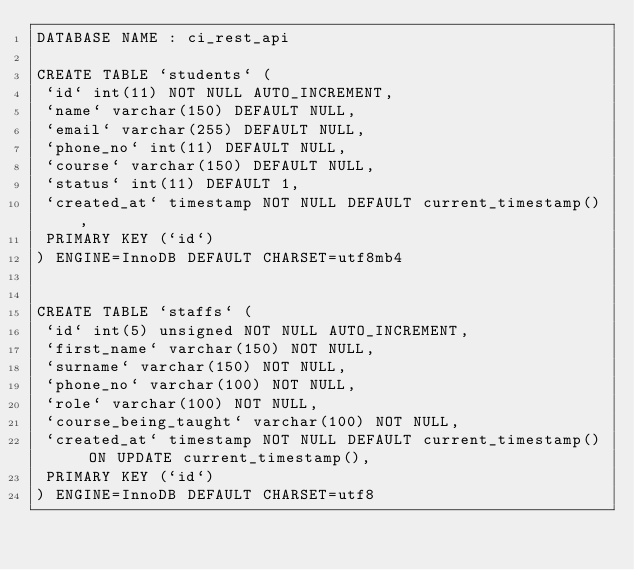<code> <loc_0><loc_0><loc_500><loc_500><_SQL_>DATABASE NAME : ci_rest_api

CREATE TABLE `students` (
 `id` int(11) NOT NULL AUTO_INCREMENT,
 `name` varchar(150) DEFAULT NULL,
 `email` varchar(255) DEFAULT NULL,
 `phone_no` int(11) DEFAULT NULL,
 `course` varchar(150) DEFAULT NULL,
 `status` int(11) DEFAULT 1,
 `created_at` timestamp NOT NULL DEFAULT current_timestamp(),
 PRIMARY KEY (`id`)
) ENGINE=InnoDB DEFAULT CHARSET=utf8mb4


CREATE TABLE `staffs` (
 `id` int(5) unsigned NOT NULL AUTO_INCREMENT,
 `first_name` varchar(150) NOT NULL,
 `surname` varchar(150) NOT NULL,
 `phone_no` varchar(100) NOT NULL,
 `role` varchar(100) NOT NULL,
 `course_being_taught` varchar(100) NOT NULL,
 `created_at` timestamp NOT NULL DEFAULT current_timestamp() ON UPDATE current_timestamp(),
 PRIMARY KEY (`id`)
) ENGINE=InnoDB DEFAULT CHARSET=utf8</code> 